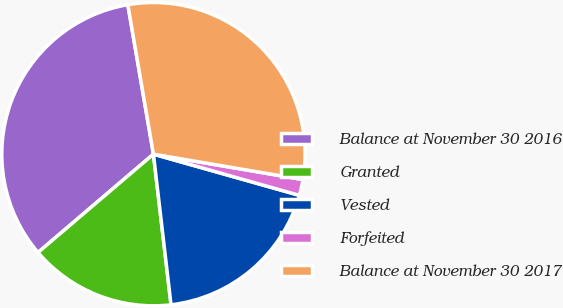Convert chart. <chart><loc_0><loc_0><loc_500><loc_500><pie_chart><fcel>Balance at November 30 2016<fcel>Granted<fcel>Vested<fcel>Forfeited<fcel>Balance at November 30 2017<nl><fcel>33.53%<fcel>15.62%<fcel>18.77%<fcel>1.7%<fcel>30.38%<nl></chart> 